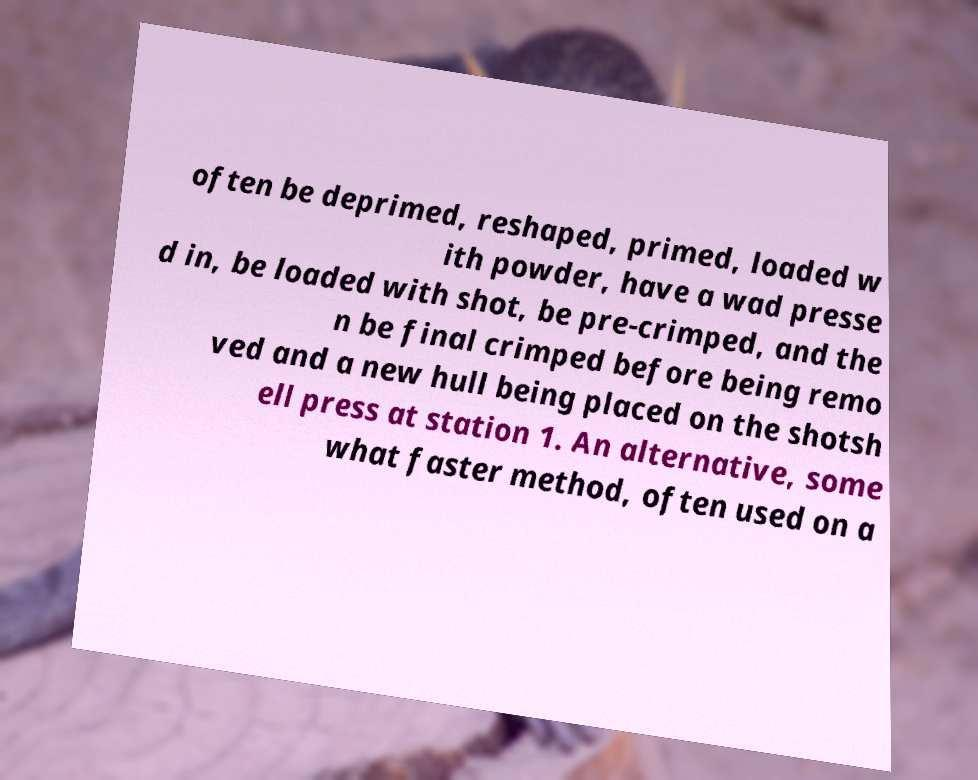For documentation purposes, I need the text within this image transcribed. Could you provide that? often be deprimed, reshaped, primed, loaded w ith powder, have a wad presse d in, be loaded with shot, be pre-crimped, and the n be final crimped before being remo ved and a new hull being placed on the shotsh ell press at station 1. An alternative, some what faster method, often used on a 